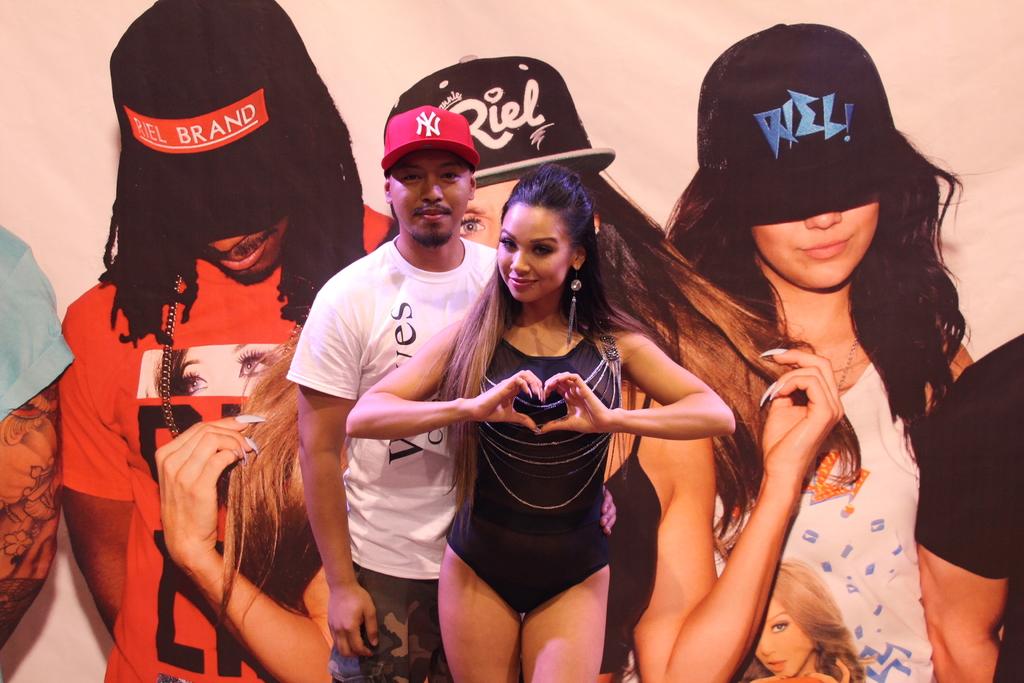What are the letters on the mans red hat?
Provide a succinct answer. Ny. What is the blue text on the hat to the right?
Your response must be concise. Riel. 